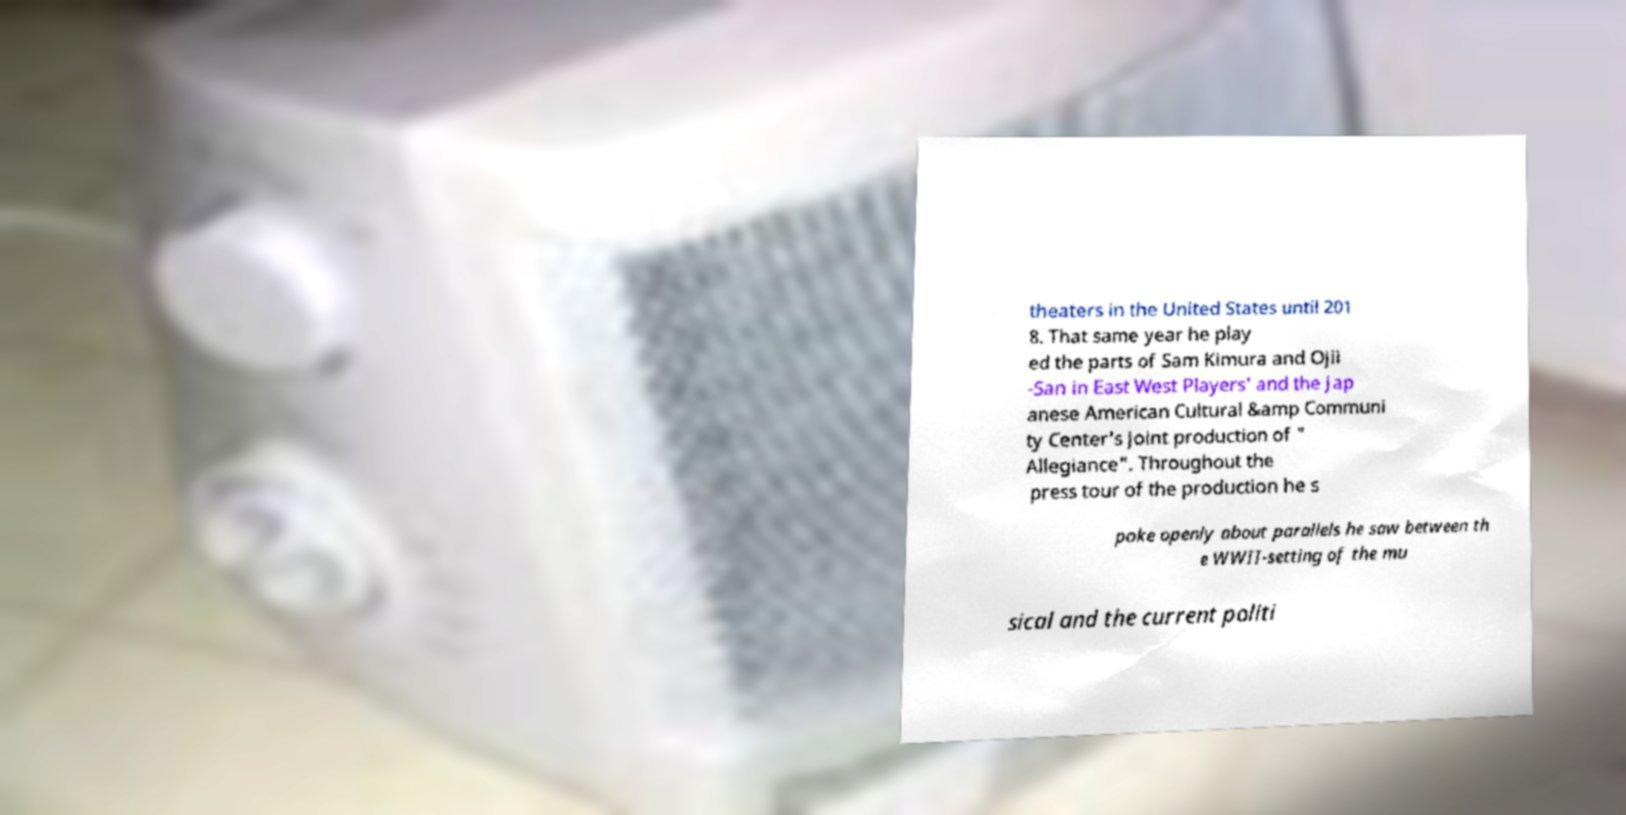Please read and relay the text visible in this image. What does it say? theaters in the United States until 201 8. That same year he play ed the parts of Sam Kimura and Ojii -San in East West Players' and the Jap anese American Cultural &amp Communi ty Center's joint production of " Allegiance". Throughout the press tour of the production he s poke openly about parallels he saw between th e WWII-setting of the mu sical and the current politi 